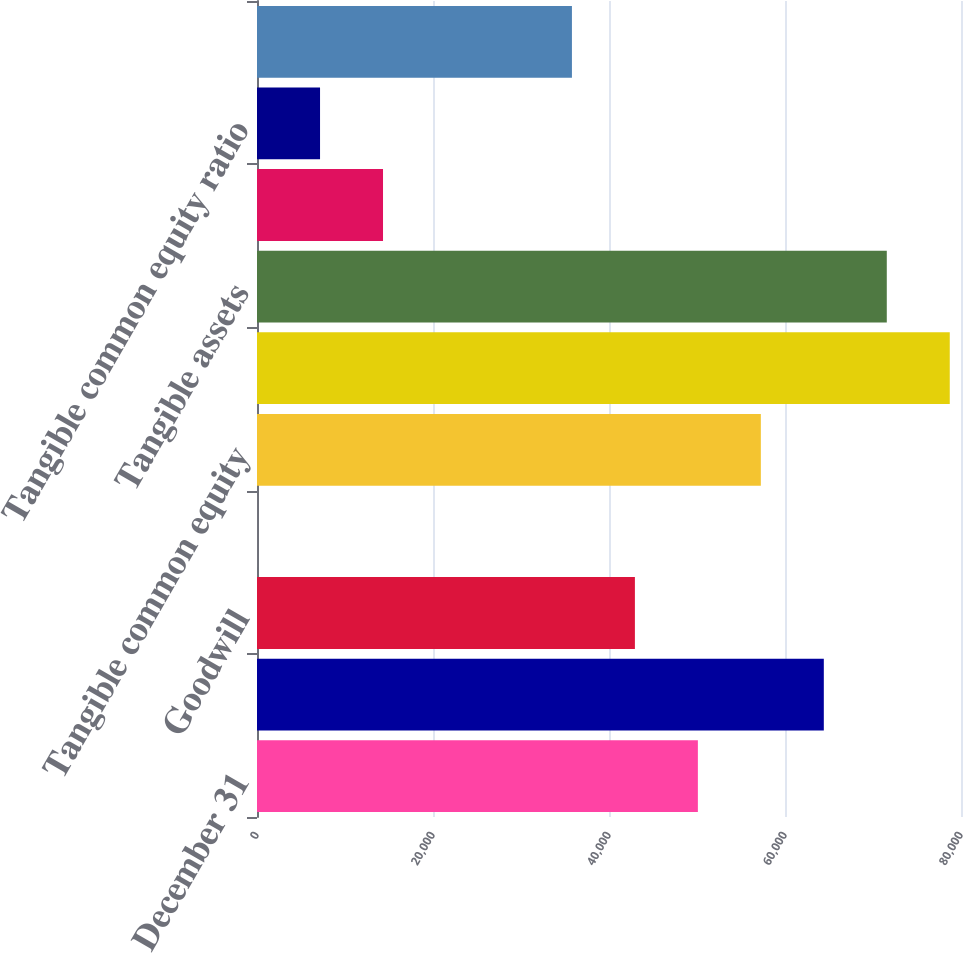Convert chart to OTSL. <chart><loc_0><loc_0><loc_500><loc_500><bar_chart><fcel>December 31<fcel>Common shareholders' equity<fcel>Goodwill<fcel>Other intangible assets<fcel>Tangible common equity<fcel>Total assets<fcel>Tangible assets<fcel>Common equity ratio<fcel>Tangible common equity ratio<fcel>Shares of common stock<nl><fcel>50099.3<fcel>64411.1<fcel>42943.4<fcel>8<fcel>57255.2<fcel>78722.9<fcel>71567<fcel>14319.8<fcel>7163.9<fcel>35787.5<nl></chart> 